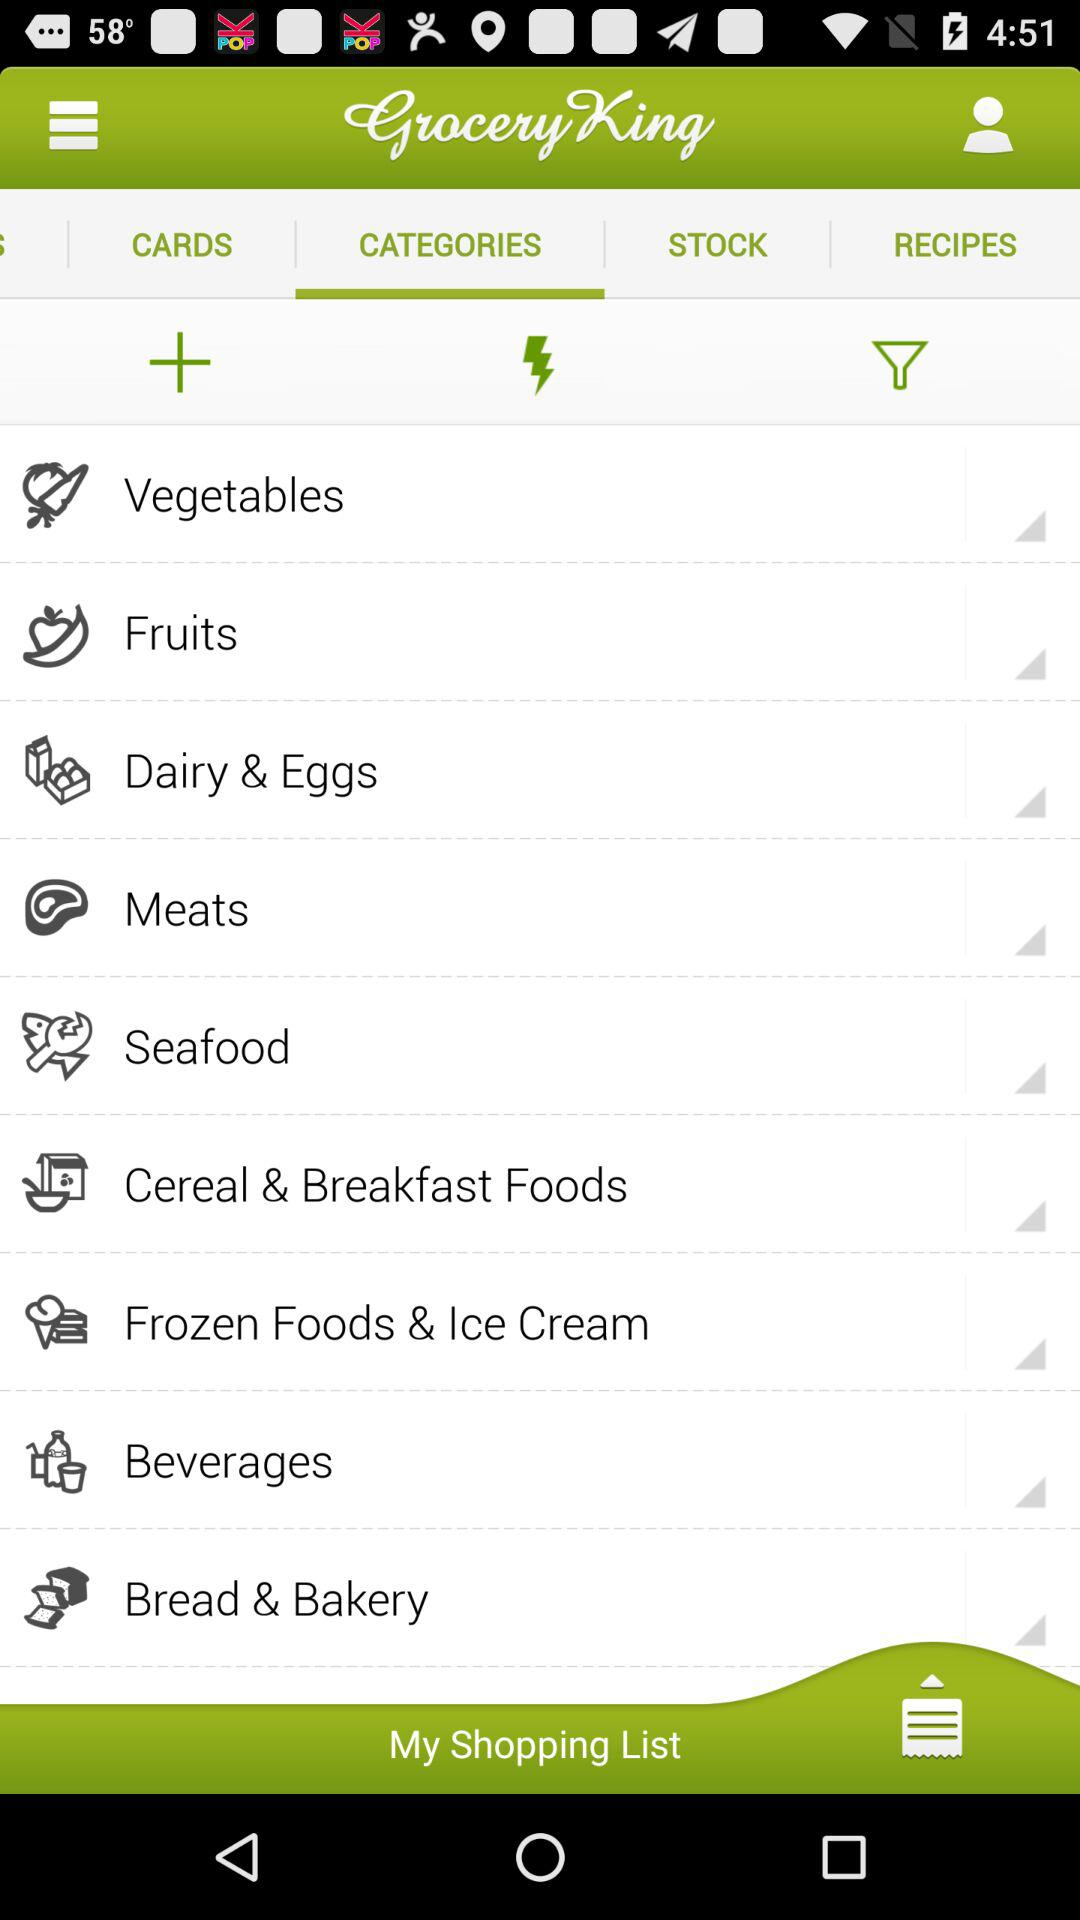What is the application name? The application name is "Grocery King". 